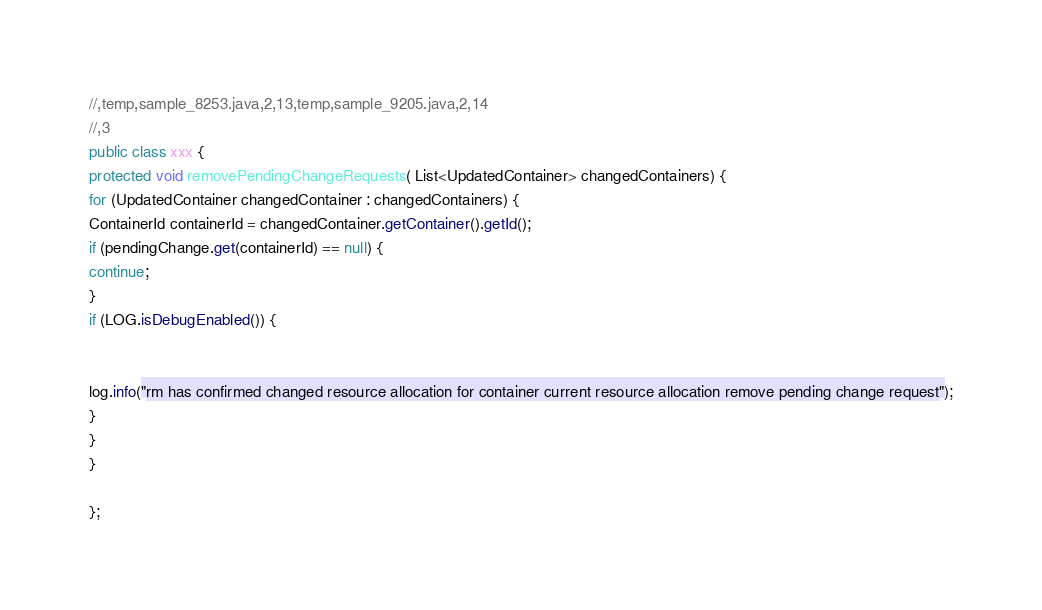Convert code to text. <code><loc_0><loc_0><loc_500><loc_500><_Java_>//,temp,sample_8253.java,2,13,temp,sample_9205.java,2,14
//,3
public class xxx {
protected void removePendingChangeRequests( List<UpdatedContainer> changedContainers) {
for (UpdatedContainer changedContainer : changedContainers) {
ContainerId containerId = changedContainer.getContainer().getId();
if (pendingChange.get(containerId) == null) {
continue;
}
if (LOG.isDebugEnabled()) {


log.info("rm has confirmed changed resource allocation for container current resource allocation remove pending change request");
}
}
}

};</code> 